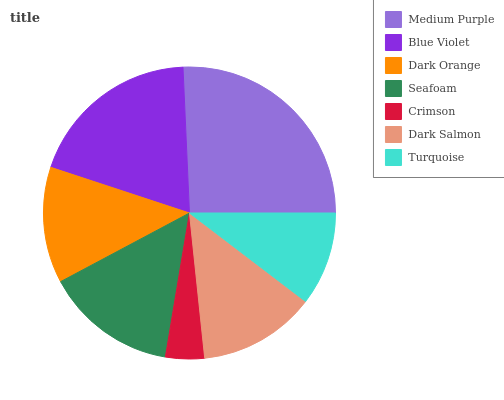Is Crimson the minimum?
Answer yes or no. Yes. Is Medium Purple the maximum?
Answer yes or no. Yes. Is Blue Violet the minimum?
Answer yes or no. No. Is Blue Violet the maximum?
Answer yes or no. No. Is Medium Purple greater than Blue Violet?
Answer yes or no. Yes. Is Blue Violet less than Medium Purple?
Answer yes or no. Yes. Is Blue Violet greater than Medium Purple?
Answer yes or no. No. Is Medium Purple less than Blue Violet?
Answer yes or no. No. Is Dark Salmon the high median?
Answer yes or no. Yes. Is Dark Salmon the low median?
Answer yes or no. Yes. Is Dark Orange the high median?
Answer yes or no. No. Is Dark Orange the low median?
Answer yes or no. No. 